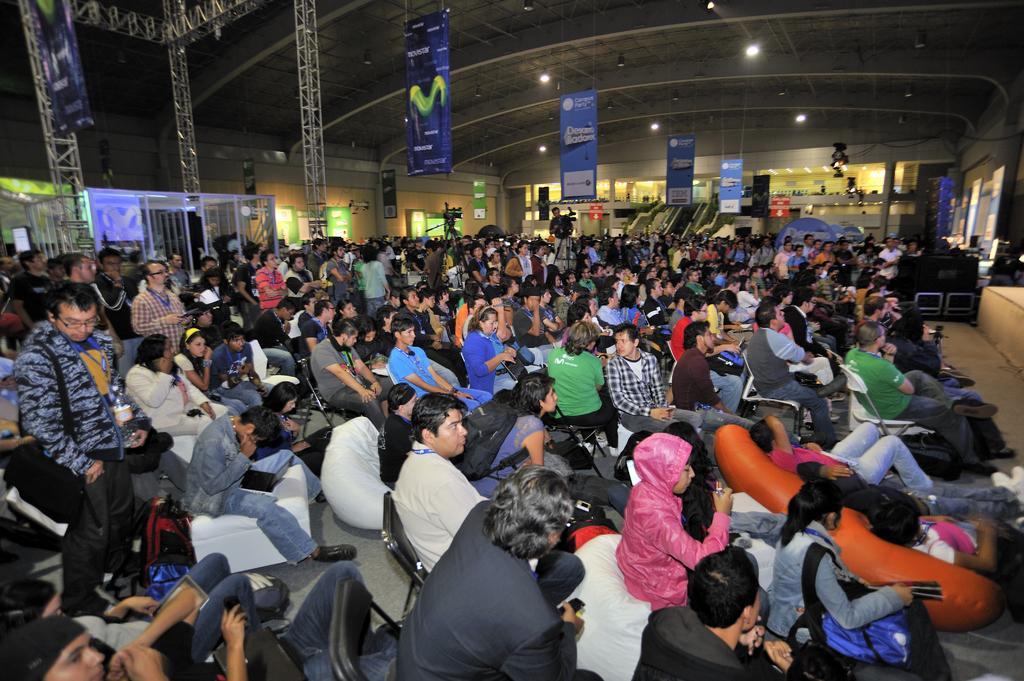In one or two sentences, can you explain what this image depicts? In this image I can see number of persons are sitting on chairs and few persons are standing. I can see few metal rods, few boards, the wall, the ceiling, few banners and few lights to the ceiling. 